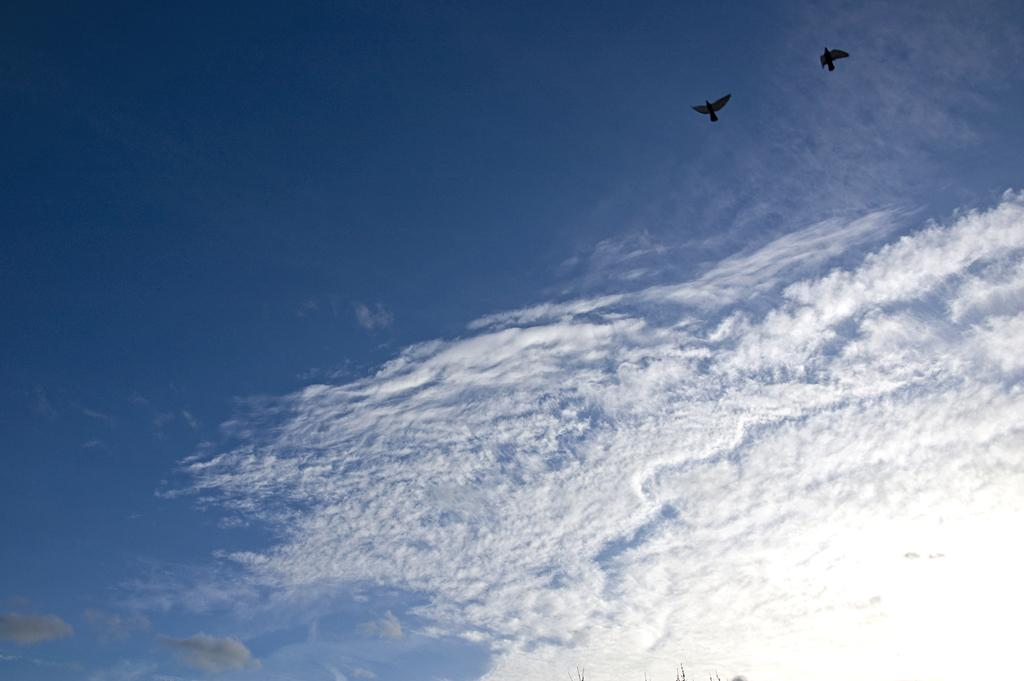How many birds are present in the image? There are two birds in the image. What are the birds doing in the image? The birds are flying in the air. What can be seen in the background of the image? There is a sky visible in the background of the image. What is the condition of the sky in the image? There are clouds in the sky. How does one check their credit balance in the image? There is no reference to credit or balance in the image, as it features two birds flying in the sky. 